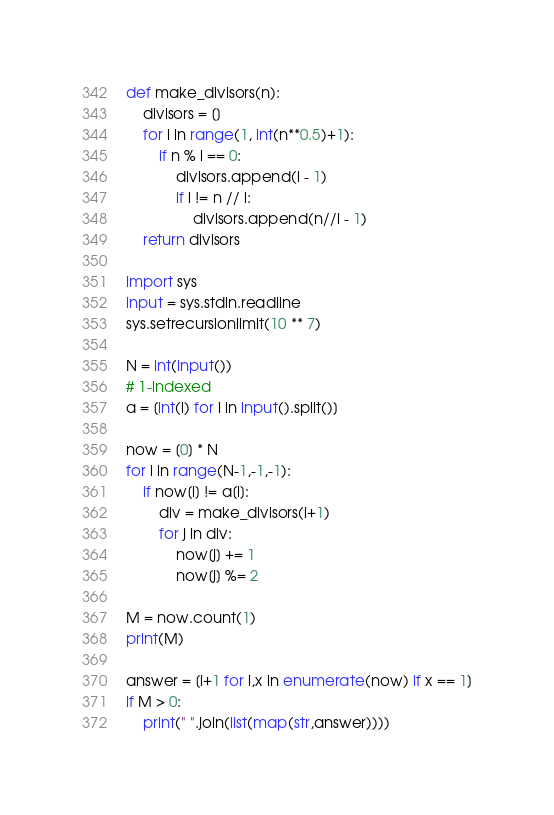<code> <loc_0><loc_0><loc_500><loc_500><_Python_>def make_divisors(n):
    divisors = []
    for i in range(1, int(n**0.5)+1):
        if n % i == 0:
            divisors.append(i - 1)
            if i != n // i:
                divisors.append(n//i - 1)
    return divisors

import sys
input = sys.stdin.readline
sys.setrecursionlimit(10 ** 7)

N = int(input())
# 1-indexed
a = [int(i) for i in input().split()]

now = [0] * N
for i in range(N-1,-1,-1):
    if now[i] != a[i]:
        div = make_divisors(i+1)
        for j in div:
            now[j] += 1
            now[j] %= 2

M = now.count(1)
print(M)

answer = [i+1 for i,x in enumerate(now) if x == 1]
if M > 0:
    print(" ".join(list(map(str,answer))))</code> 